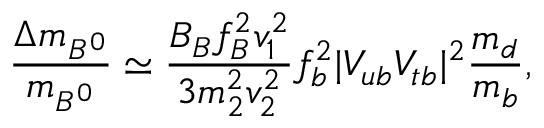<formula> <loc_0><loc_0><loc_500><loc_500>{ \frac { \Delta m _ { B ^ { 0 } } } { m _ { B ^ { 0 } } } } \simeq { \frac { B _ { B } f _ { B } ^ { 2 } v _ { 1 } ^ { 2 } } { 3 m _ { 2 } ^ { 2 } v _ { 2 } ^ { 2 } } } f _ { b } ^ { 2 } | V _ { u b } V _ { t b } | ^ { 2 } { \frac { m _ { d } } { m _ { b } } } ,</formula> 